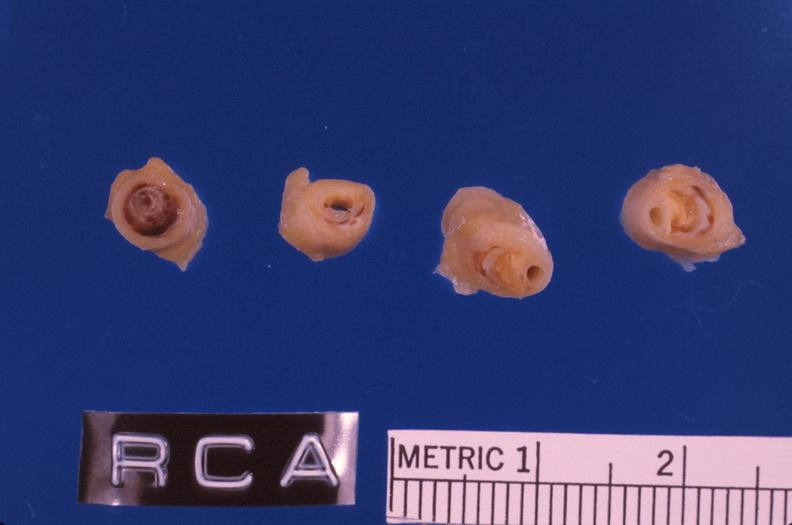what does this image show?
Answer the question using a single word or phrase. Coronary artery atherosclerosis 